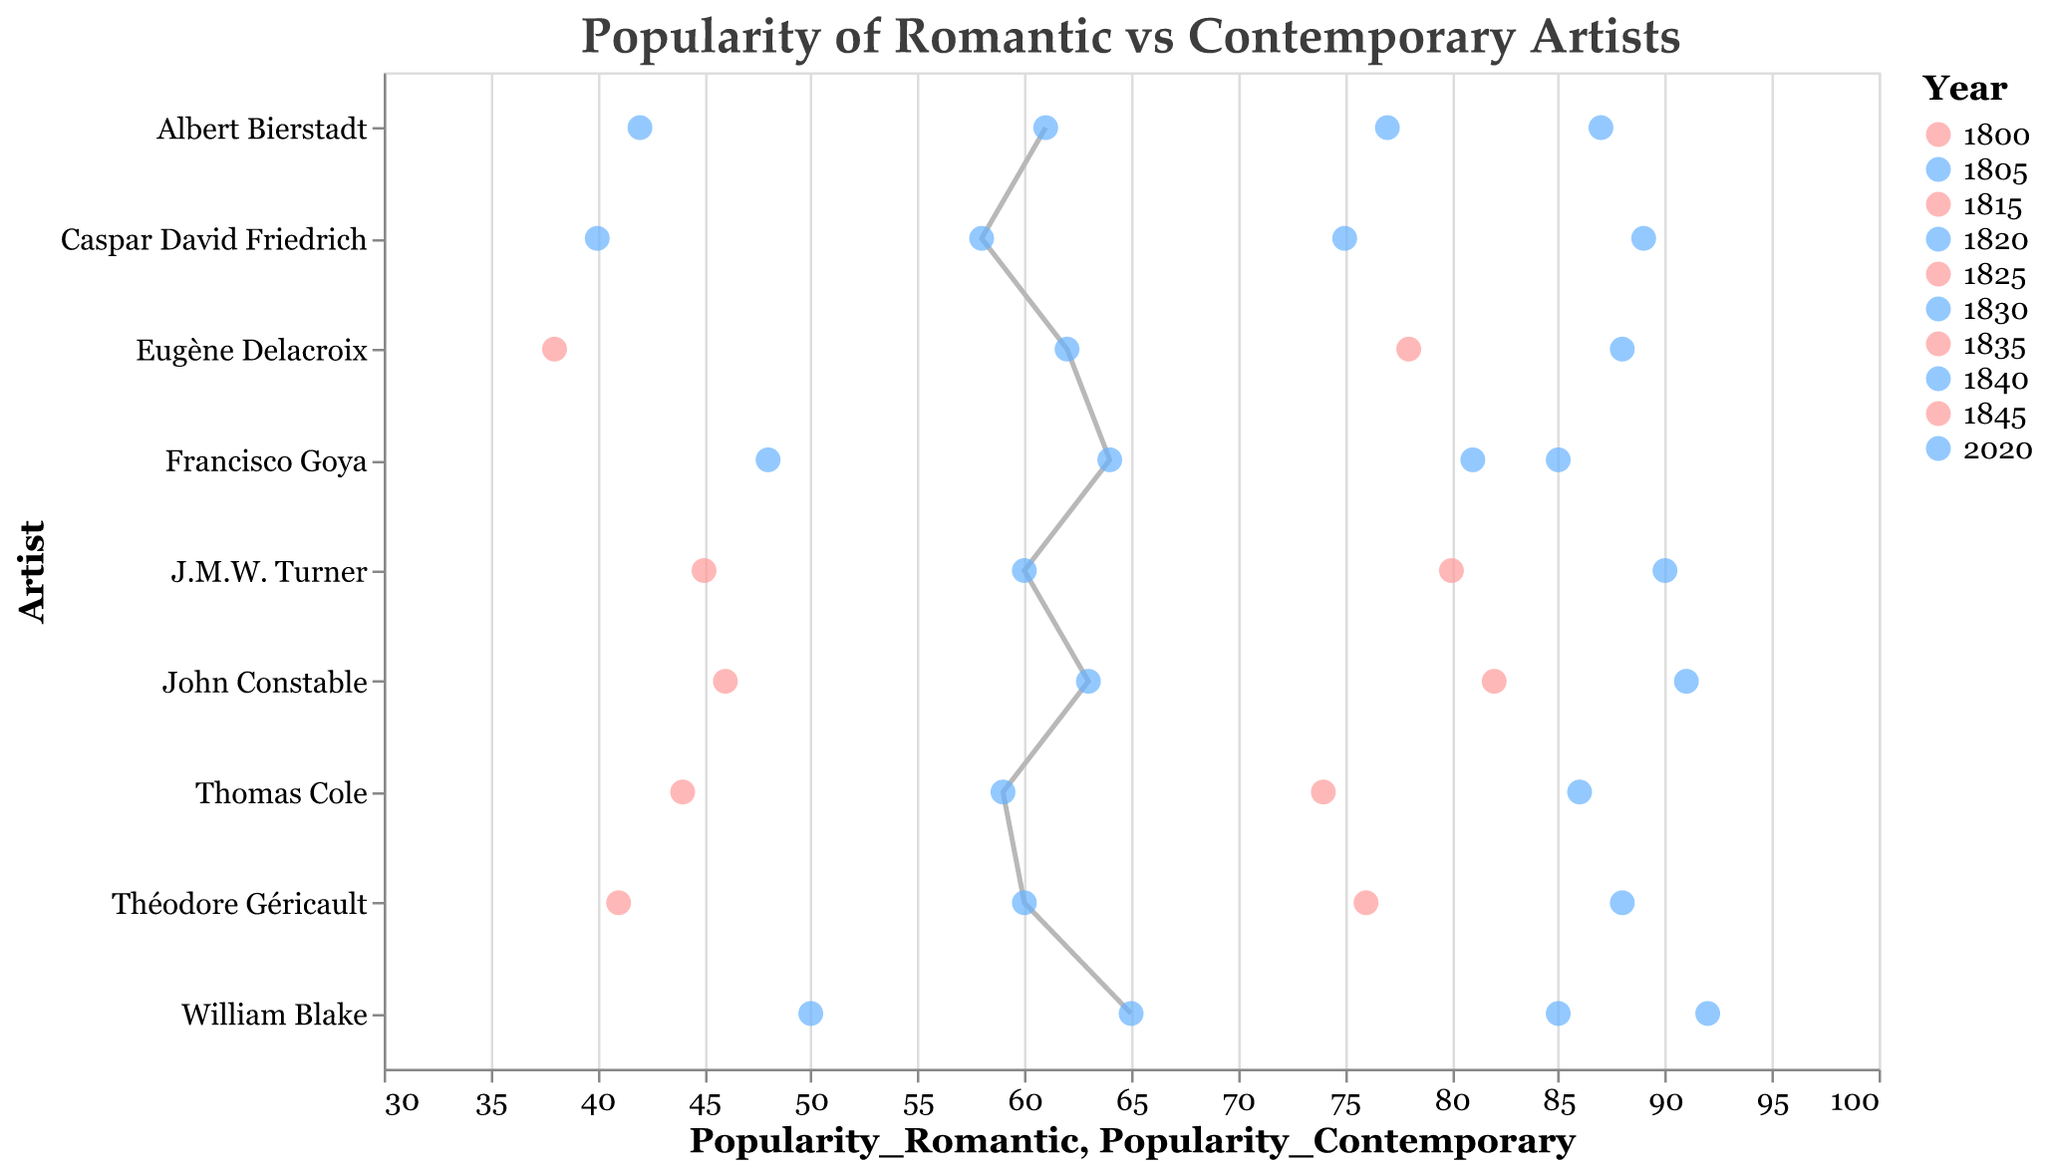What's the title of the plot? The title is the text at the top of the plot. It's written in a larger font to make it stand out.
Answer: Popularity of Romantic vs Contemporary Artists How many artists are compared in the plot? Count the unique artist names on the y-axis.
Answer: 9 Which artist has the highest contemporary popularity in 2020? Look at the "Contemporary" points in 2020 and identify the artist with the highest value on the x-axis.
Answer: William Blake What is the popularity change for William Blake from 1820 to 2020? Find William Blake's popularity in 1820 and 2020 and calculate the difference. 1820: 85, 2020: 65. So, 85 - 65 = 20.
Answer: 20 What is the average popularity of Romantic artists in 2020? Sum the popularity values for all Romantic artists in 2020 and divide by the number of artists (60 + 58 + 62 + 65 + 63 + 64 + 59 + 61 + 60 = 552; 552 / 9 = 61.3).
Answer: 61.3 Who had the greater difference in popularity between the Romantic and Contemporary periods: Turner or Blake? Calculate the difference for both artists between the two periods. Turner: 80 - 90 = -10, Blake: 85 - 92 = -7. Compare the differences to determine who had the greater gap.
Answer: Turner (-10) Which artist was more popular in the Romantic era: John Constable or Francisco Goya? Compare their Romantic popularity values from the plot. Goya: 81, Constable: 82.
Answer: John Constable By how much did Caspar David Friedrich's popularity increase from the Romantic to the Contemporary period? Subtract Romantic era popularity from Contemporary era. Romantic: 75, Contemporary: 89. So, 89 - 75 = 14.
Answer: 14 Which artist's popularity remained closest to their Romantic era popularity in 2020? Compare the absolute differences between each artist's Romantic and Contemporary popularity values and find the smallest one.
Answer: Eugène Delacroix What do the different colors of the points on the Dumbbell Plot represent? The colors represent the two years compared — Romantic period and 2020, with different colors mapping to each.
Answer: Time periods (Romantic and Contemporary) 